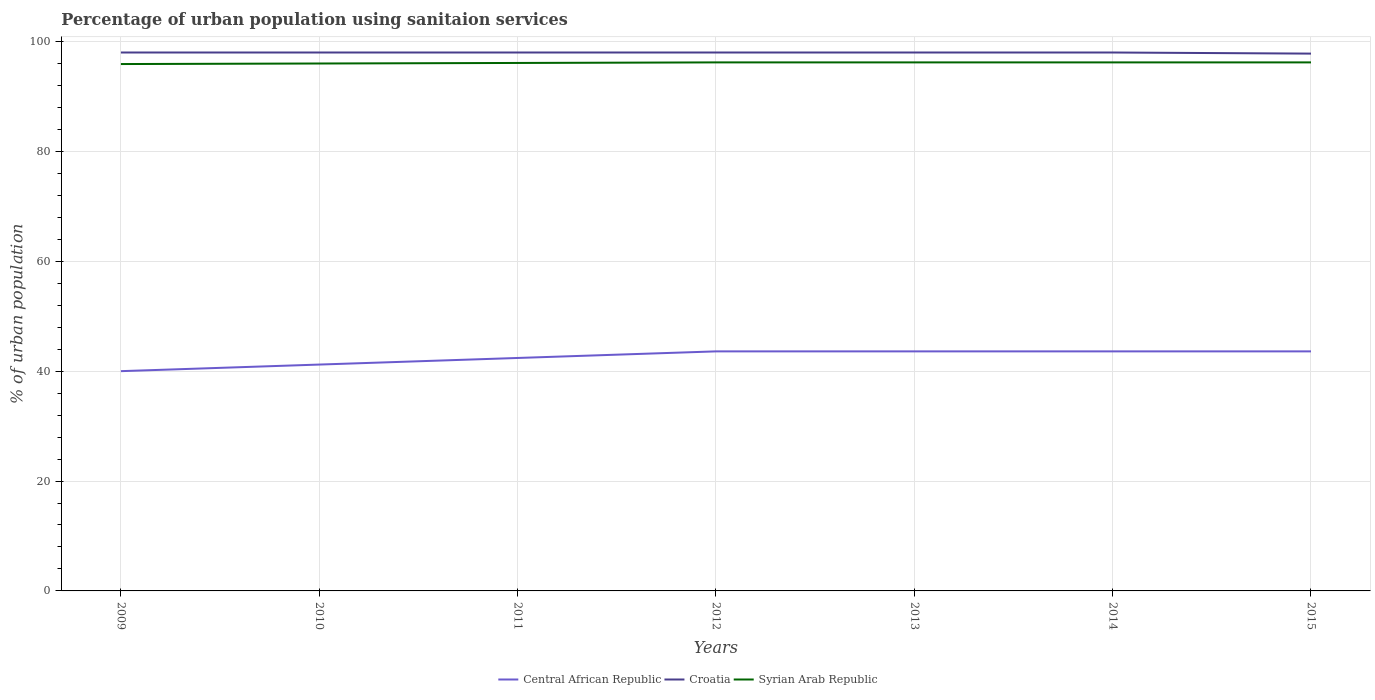How many different coloured lines are there?
Offer a terse response. 3. Is the number of lines equal to the number of legend labels?
Your answer should be very brief. Yes. Across all years, what is the maximum percentage of urban population using sanitaion services in Syrian Arab Republic?
Provide a short and direct response. 95.9. In which year was the percentage of urban population using sanitaion services in Croatia maximum?
Offer a very short reply. 2015. What is the total percentage of urban population using sanitaion services in Syrian Arab Republic in the graph?
Offer a terse response. -0.2. What is the difference between the highest and the second highest percentage of urban population using sanitaion services in Central African Republic?
Provide a succinct answer. 3.6. Is the percentage of urban population using sanitaion services in Croatia strictly greater than the percentage of urban population using sanitaion services in Syrian Arab Republic over the years?
Offer a very short reply. No. What is the title of the graph?
Make the answer very short. Percentage of urban population using sanitaion services. What is the label or title of the X-axis?
Keep it short and to the point. Years. What is the label or title of the Y-axis?
Provide a succinct answer. % of urban population. What is the % of urban population in Central African Republic in 2009?
Offer a very short reply. 40. What is the % of urban population in Croatia in 2009?
Provide a short and direct response. 98. What is the % of urban population of Syrian Arab Republic in 2009?
Offer a terse response. 95.9. What is the % of urban population in Central African Republic in 2010?
Your response must be concise. 41.2. What is the % of urban population in Croatia in 2010?
Offer a terse response. 98. What is the % of urban population of Syrian Arab Republic in 2010?
Offer a very short reply. 96. What is the % of urban population of Central African Republic in 2011?
Your answer should be compact. 42.4. What is the % of urban population of Croatia in 2011?
Your answer should be compact. 98. What is the % of urban population of Syrian Arab Republic in 2011?
Provide a succinct answer. 96.1. What is the % of urban population of Central African Republic in 2012?
Ensure brevity in your answer.  43.6. What is the % of urban population of Syrian Arab Republic in 2012?
Give a very brief answer. 96.2. What is the % of urban population of Central African Republic in 2013?
Provide a short and direct response. 43.6. What is the % of urban population of Syrian Arab Republic in 2013?
Offer a terse response. 96.2. What is the % of urban population in Central African Republic in 2014?
Provide a succinct answer. 43.6. What is the % of urban population of Syrian Arab Republic in 2014?
Provide a short and direct response. 96.2. What is the % of urban population in Central African Republic in 2015?
Provide a succinct answer. 43.6. What is the % of urban population in Croatia in 2015?
Your answer should be very brief. 97.8. What is the % of urban population in Syrian Arab Republic in 2015?
Offer a very short reply. 96.2. Across all years, what is the maximum % of urban population of Central African Republic?
Your response must be concise. 43.6. Across all years, what is the maximum % of urban population of Croatia?
Your answer should be very brief. 98. Across all years, what is the maximum % of urban population of Syrian Arab Republic?
Give a very brief answer. 96.2. Across all years, what is the minimum % of urban population of Central African Republic?
Keep it short and to the point. 40. Across all years, what is the minimum % of urban population in Croatia?
Make the answer very short. 97.8. Across all years, what is the minimum % of urban population in Syrian Arab Republic?
Provide a short and direct response. 95.9. What is the total % of urban population in Central African Republic in the graph?
Offer a very short reply. 298. What is the total % of urban population of Croatia in the graph?
Give a very brief answer. 685.8. What is the total % of urban population in Syrian Arab Republic in the graph?
Make the answer very short. 672.8. What is the difference between the % of urban population in Central African Republic in 2009 and that in 2012?
Ensure brevity in your answer.  -3.6. What is the difference between the % of urban population of Croatia in 2009 and that in 2012?
Provide a succinct answer. 0. What is the difference between the % of urban population in Central African Republic in 2009 and that in 2013?
Keep it short and to the point. -3.6. What is the difference between the % of urban population of Croatia in 2009 and that in 2013?
Offer a terse response. 0. What is the difference between the % of urban population in Syrian Arab Republic in 2009 and that in 2013?
Make the answer very short. -0.3. What is the difference between the % of urban population in Central African Republic in 2009 and that in 2014?
Make the answer very short. -3.6. What is the difference between the % of urban population of Croatia in 2009 and that in 2015?
Offer a very short reply. 0.2. What is the difference between the % of urban population of Syrian Arab Republic in 2009 and that in 2015?
Provide a short and direct response. -0.3. What is the difference between the % of urban population in Croatia in 2010 and that in 2011?
Provide a short and direct response. 0. What is the difference between the % of urban population of Central African Republic in 2010 and that in 2012?
Ensure brevity in your answer.  -2.4. What is the difference between the % of urban population of Croatia in 2010 and that in 2013?
Make the answer very short. 0. What is the difference between the % of urban population of Syrian Arab Republic in 2010 and that in 2013?
Your response must be concise. -0.2. What is the difference between the % of urban population of Syrian Arab Republic in 2010 and that in 2015?
Offer a very short reply. -0.2. What is the difference between the % of urban population in Syrian Arab Republic in 2011 and that in 2012?
Keep it short and to the point. -0.1. What is the difference between the % of urban population in Central African Republic in 2011 and that in 2013?
Provide a short and direct response. -1.2. What is the difference between the % of urban population in Syrian Arab Republic in 2011 and that in 2013?
Make the answer very short. -0.1. What is the difference between the % of urban population in Central African Republic in 2011 and that in 2014?
Provide a succinct answer. -1.2. What is the difference between the % of urban population in Croatia in 2011 and that in 2014?
Make the answer very short. 0. What is the difference between the % of urban population in Syrian Arab Republic in 2011 and that in 2014?
Offer a very short reply. -0.1. What is the difference between the % of urban population of Croatia in 2011 and that in 2015?
Your answer should be very brief. 0.2. What is the difference between the % of urban population in Croatia in 2012 and that in 2014?
Keep it short and to the point. 0. What is the difference between the % of urban population of Croatia in 2012 and that in 2015?
Provide a short and direct response. 0.2. What is the difference between the % of urban population in Croatia in 2013 and that in 2014?
Your response must be concise. 0. What is the difference between the % of urban population of Croatia in 2013 and that in 2015?
Keep it short and to the point. 0.2. What is the difference between the % of urban population in Syrian Arab Republic in 2013 and that in 2015?
Give a very brief answer. 0. What is the difference between the % of urban population in Central African Republic in 2014 and that in 2015?
Offer a terse response. 0. What is the difference between the % of urban population of Croatia in 2014 and that in 2015?
Offer a terse response. 0.2. What is the difference between the % of urban population in Central African Republic in 2009 and the % of urban population in Croatia in 2010?
Your answer should be very brief. -58. What is the difference between the % of urban population of Central African Republic in 2009 and the % of urban population of Syrian Arab Republic in 2010?
Your response must be concise. -56. What is the difference between the % of urban population in Central African Republic in 2009 and the % of urban population in Croatia in 2011?
Keep it short and to the point. -58. What is the difference between the % of urban population of Central African Republic in 2009 and the % of urban population of Syrian Arab Republic in 2011?
Give a very brief answer. -56.1. What is the difference between the % of urban population in Central African Republic in 2009 and the % of urban population in Croatia in 2012?
Offer a very short reply. -58. What is the difference between the % of urban population in Central African Republic in 2009 and the % of urban population in Syrian Arab Republic in 2012?
Offer a terse response. -56.2. What is the difference between the % of urban population of Croatia in 2009 and the % of urban population of Syrian Arab Republic in 2012?
Keep it short and to the point. 1.8. What is the difference between the % of urban population in Central African Republic in 2009 and the % of urban population in Croatia in 2013?
Your answer should be compact. -58. What is the difference between the % of urban population of Central African Republic in 2009 and the % of urban population of Syrian Arab Republic in 2013?
Give a very brief answer. -56.2. What is the difference between the % of urban population of Croatia in 2009 and the % of urban population of Syrian Arab Republic in 2013?
Your response must be concise. 1.8. What is the difference between the % of urban population in Central African Republic in 2009 and the % of urban population in Croatia in 2014?
Offer a very short reply. -58. What is the difference between the % of urban population of Central African Republic in 2009 and the % of urban population of Syrian Arab Republic in 2014?
Keep it short and to the point. -56.2. What is the difference between the % of urban population in Croatia in 2009 and the % of urban population in Syrian Arab Republic in 2014?
Provide a succinct answer. 1.8. What is the difference between the % of urban population in Central African Republic in 2009 and the % of urban population in Croatia in 2015?
Your response must be concise. -57.8. What is the difference between the % of urban population of Central African Republic in 2009 and the % of urban population of Syrian Arab Republic in 2015?
Keep it short and to the point. -56.2. What is the difference between the % of urban population of Croatia in 2009 and the % of urban population of Syrian Arab Republic in 2015?
Ensure brevity in your answer.  1.8. What is the difference between the % of urban population of Central African Republic in 2010 and the % of urban population of Croatia in 2011?
Your answer should be very brief. -56.8. What is the difference between the % of urban population in Central African Republic in 2010 and the % of urban population in Syrian Arab Republic in 2011?
Keep it short and to the point. -54.9. What is the difference between the % of urban population in Croatia in 2010 and the % of urban population in Syrian Arab Republic in 2011?
Provide a short and direct response. 1.9. What is the difference between the % of urban population of Central African Republic in 2010 and the % of urban population of Croatia in 2012?
Ensure brevity in your answer.  -56.8. What is the difference between the % of urban population of Central African Republic in 2010 and the % of urban population of Syrian Arab Republic in 2012?
Ensure brevity in your answer.  -55. What is the difference between the % of urban population of Central African Republic in 2010 and the % of urban population of Croatia in 2013?
Keep it short and to the point. -56.8. What is the difference between the % of urban population of Central African Republic in 2010 and the % of urban population of Syrian Arab Republic in 2013?
Your answer should be compact. -55. What is the difference between the % of urban population in Croatia in 2010 and the % of urban population in Syrian Arab Republic in 2013?
Keep it short and to the point. 1.8. What is the difference between the % of urban population in Central African Republic in 2010 and the % of urban population in Croatia in 2014?
Keep it short and to the point. -56.8. What is the difference between the % of urban population in Central African Republic in 2010 and the % of urban population in Syrian Arab Republic in 2014?
Ensure brevity in your answer.  -55. What is the difference between the % of urban population of Croatia in 2010 and the % of urban population of Syrian Arab Republic in 2014?
Keep it short and to the point. 1.8. What is the difference between the % of urban population of Central African Republic in 2010 and the % of urban population of Croatia in 2015?
Ensure brevity in your answer.  -56.6. What is the difference between the % of urban population in Central African Republic in 2010 and the % of urban population in Syrian Arab Republic in 2015?
Give a very brief answer. -55. What is the difference between the % of urban population of Croatia in 2010 and the % of urban population of Syrian Arab Republic in 2015?
Make the answer very short. 1.8. What is the difference between the % of urban population in Central African Republic in 2011 and the % of urban population in Croatia in 2012?
Your answer should be very brief. -55.6. What is the difference between the % of urban population in Central African Republic in 2011 and the % of urban population in Syrian Arab Republic in 2012?
Keep it short and to the point. -53.8. What is the difference between the % of urban population of Croatia in 2011 and the % of urban population of Syrian Arab Republic in 2012?
Your answer should be very brief. 1.8. What is the difference between the % of urban population of Central African Republic in 2011 and the % of urban population of Croatia in 2013?
Offer a terse response. -55.6. What is the difference between the % of urban population in Central African Republic in 2011 and the % of urban population in Syrian Arab Republic in 2013?
Ensure brevity in your answer.  -53.8. What is the difference between the % of urban population of Central African Republic in 2011 and the % of urban population of Croatia in 2014?
Provide a succinct answer. -55.6. What is the difference between the % of urban population in Central African Republic in 2011 and the % of urban population in Syrian Arab Republic in 2014?
Offer a very short reply. -53.8. What is the difference between the % of urban population of Croatia in 2011 and the % of urban population of Syrian Arab Republic in 2014?
Your answer should be compact. 1.8. What is the difference between the % of urban population of Central African Republic in 2011 and the % of urban population of Croatia in 2015?
Your answer should be very brief. -55.4. What is the difference between the % of urban population in Central African Republic in 2011 and the % of urban population in Syrian Arab Republic in 2015?
Ensure brevity in your answer.  -53.8. What is the difference between the % of urban population in Central African Republic in 2012 and the % of urban population in Croatia in 2013?
Your answer should be compact. -54.4. What is the difference between the % of urban population of Central African Republic in 2012 and the % of urban population of Syrian Arab Republic in 2013?
Offer a terse response. -52.6. What is the difference between the % of urban population in Croatia in 2012 and the % of urban population in Syrian Arab Republic in 2013?
Ensure brevity in your answer.  1.8. What is the difference between the % of urban population of Central African Republic in 2012 and the % of urban population of Croatia in 2014?
Keep it short and to the point. -54.4. What is the difference between the % of urban population of Central African Republic in 2012 and the % of urban population of Syrian Arab Republic in 2014?
Make the answer very short. -52.6. What is the difference between the % of urban population in Croatia in 2012 and the % of urban population in Syrian Arab Republic in 2014?
Your response must be concise. 1.8. What is the difference between the % of urban population in Central African Republic in 2012 and the % of urban population in Croatia in 2015?
Provide a succinct answer. -54.2. What is the difference between the % of urban population of Central African Republic in 2012 and the % of urban population of Syrian Arab Republic in 2015?
Offer a terse response. -52.6. What is the difference between the % of urban population of Central African Republic in 2013 and the % of urban population of Croatia in 2014?
Offer a very short reply. -54.4. What is the difference between the % of urban population in Central African Republic in 2013 and the % of urban population in Syrian Arab Republic in 2014?
Offer a very short reply. -52.6. What is the difference between the % of urban population of Croatia in 2013 and the % of urban population of Syrian Arab Republic in 2014?
Give a very brief answer. 1.8. What is the difference between the % of urban population in Central African Republic in 2013 and the % of urban population in Croatia in 2015?
Your answer should be compact. -54.2. What is the difference between the % of urban population in Central African Republic in 2013 and the % of urban population in Syrian Arab Republic in 2015?
Offer a terse response. -52.6. What is the difference between the % of urban population in Central African Republic in 2014 and the % of urban population in Croatia in 2015?
Your response must be concise. -54.2. What is the difference between the % of urban population of Central African Republic in 2014 and the % of urban population of Syrian Arab Republic in 2015?
Give a very brief answer. -52.6. What is the average % of urban population in Central African Republic per year?
Keep it short and to the point. 42.57. What is the average % of urban population of Croatia per year?
Your response must be concise. 97.97. What is the average % of urban population of Syrian Arab Republic per year?
Keep it short and to the point. 96.11. In the year 2009, what is the difference between the % of urban population of Central African Republic and % of urban population of Croatia?
Your answer should be compact. -58. In the year 2009, what is the difference between the % of urban population in Central African Republic and % of urban population in Syrian Arab Republic?
Give a very brief answer. -55.9. In the year 2010, what is the difference between the % of urban population in Central African Republic and % of urban population in Croatia?
Your answer should be compact. -56.8. In the year 2010, what is the difference between the % of urban population in Central African Republic and % of urban population in Syrian Arab Republic?
Offer a very short reply. -54.8. In the year 2011, what is the difference between the % of urban population in Central African Republic and % of urban population in Croatia?
Ensure brevity in your answer.  -55.6. In the year 2011, what is the difference between the % of urban population of Central African Republic and % of urban population of Syrian Arab Republic?
Provide a succinct answer. -53.7. In the year 2012, what is the difference between the % of urban population of Central African Republic and % of urban population of Croatia?
Give a very brief answer. -54.4. In the year 2012, what is the difference between the % of urban population in Central African Republic and % of urban population in Syrian Arab Republic?
Provide a short and direct response. -52.6. In the year 2012, what is the difference between the % of urban population in Croatia and % of urban population in Syrian Arab Republic?
Provide a succinct answer. 1.8. In the year 2013, what is the difference between the % of urban population of Central African Republic and % of urban population of Croatia?
Keep it short and to the point. -54.4. In the year 2013, what is the difference between the % of urban population of Central African Republic and % of urban population of Syrian Arab Republic?
Your answer should be very brief. -52.6. In the year 2013, what is the difference between the % of urban population of Croatia and % of urban population of Syrian Arab Republic?
Your answer should be compact. 1.8. In the year 2014, what is the difference between the % of urban population in Central African Republic and % of urban population in Croatia?
Offer a terse response. -54.4. In the year 2014, what is the difference between the % of urban population of Central African Republic and % of urban population of Syrian Arab Republic?
Your response must be concise. -52.6. In the year 2014, what is the difference between the % of urban population of Croatia and % of urban population of Syrian Arab Republic?
Your answer should be very brief. 1.8. In the year 2015, what is the difference between the % of urban population in Central African Republic and % of urban population in Croatia?
Your answer should be compact. -54.2. In the year 2015, what is the difference between the % of urban population of Central African Republic and % of urban population of Syrian Arab Republic?
Ensure brevity in your answer.  -52.6. What is the ratio of the % of urban population of Central African Republic in 2009 to that in 2010?
Provide a succinct answer. 0.97. What is the ratio of the % of urban population in Syrian Arab Republic in 2009 to that in 2010?
Provide a short and direct response. 1. What is the ratio of the % of urban population in Central African Republic in 2009 to that in 2011?
Provide a succinct answer. 0.94. What is the ratio of the % of urban population in Central African Republic in 2009 to that in 2012?
Your response must be concise. 0.92. What is the ratio of the % of urban population of Syrian Arab Republic in 2009 to that in 2012?
Your response must be concise. 1. What is the ratio of the % of urban population in Central African Republic in 2009 to that in 2013?
Your answer should be compact. 0.92. What is the ratio of the % of urban population in Syrian Arab Republic in 2009 to that in 2013?
Offer a terse response. 1. What is the ratio of the % of urban population in Central African Republic in 2009 to that in 2014?
Your response must be concise. 0.92. What is the ratio of the % of urban population of Central African Republic in 2009 to that in 2015?
Provide a succinct answer. 0.92. What is the ratio of the % of urban population in Syrian Arab Republic in 2009 to that in 2015?
Keep it short and to the point. 1. What is the ratio of the % of urban population in Central African Republic in 2010 to that in 2011?
Your answer should be compact. 0.97. What is the ratio of the % of urban population of Central African Republic in 2010 to that in 2012?
Give a very brief answer. 0.94. What is the ratio of the % of urban population of Croatia in 2010 to that in 2012?
Provide a short and direct response. 1. What is the ratio of the % of urban population of Syrian Arab Republic in 2010 to that in 2012?
Provide a short and direct response. 1. What is the ratio of the % of urban population in Central African Republic in 2010 to that in 2013?
Make the answer very short. 0.94. What is the ratio of the % of urban population of Syrian Arab Republic in 2010 to that in 2013?
Give a very brief answer. 1. What is the ratio of the % of urban population in Central African Republic in 2010 to that in 2014?
Keep it short and to the point. 0.94. What is the ratio of the % of urban population of Syrian Arab Republic in 2010 to that in 2014?
Offer a terse response. 1. What is the ratio of the % of urban population of Central African Republic in 2010 to that in 2015?
Offer a terse response. 0.94. What is the ratio of the % of urban population in Syrian Arab Republic in 2010 to that in 2015?
Your response must be concise. 1. What is the ratio of the % of urban population of Central African Republic in 2011 to that in 2012?
Make the answer very short. 0.97. What is the ratio of the % of urban population in Croatia in 2011 to that in 2012?
Provide a short and direct response. 1. What is the ratio of the % of urban population in Central African Republic in 2011 to that in 2013?
Make the answer very short. 0.97. What is the ratio of the % of urban population of Croatia in 2011 to that in 2013?
Provide a succinct answer. 1. What is the ratio of the % of urban population in Central African Republic in 2011 to that in 2014?
Your response must be concise. 0.97. What is the ratio of the % of urban population in Croatia in 2011 to that in 2014?
Your response must be concise. 1. What is the ratio of the % of urban population in Central African Republic in 2011 to that in 2015?
Your answer should be very brief. 0.97. What is the ratio of the % of urban population in Syrian Arab Republic in 2011 to that in 2015?
Provide a short and direct response. 1. What is the ratio of the % of urban population in Croatia in 2012 to that in 2013?
Offer a terse response. 1. What is the ratio of the % of urban population in Syrian Arab Republic in 2012 to that in 2013?
Give a very brief answer. 1. What is the ratio of the % of urban population of Central African Republic in 2012 to that in 2015?
Offer a very short reply. 1. What is the ratio of the % of urban population in Croatia in 2012 to that in 2015?
Provide a succinct answer. 1. What is the ratio of the % of urban population of Croatia in 2013 to that in 2015?
Offer a terse response. 1. What is the ratio of the % of urban population of Croatia in 2014 to that in 2015?
Give a very brief answer. 1. What is the difference between the highest and the lowest % of urban population of Central African Republic?
Make the answer very short. 3.6. What is the difference between the highest and the lowest % of urban population of Croatia?
Provide a short and direct response. 0.2. What is the difference between the highest and the lowest % of urban population in Syrian Arab Republic?
Offer a very short reply. 0.3. 